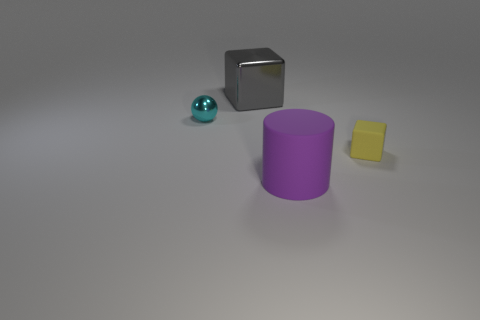Add 2 big purple cylinders. How many objects exist? 6 Subtract all cylinders. How many objects are left? 3 Add 3 cyan metal balls. How many cyan metal balls are left? 4 Add 3 rubber blocks. How many rubber blocks exist? 4 Subtract 0 green blocks. How many objects are left? 4 Subtract all tiny cyan spheres. Subtract all yellow rubber cubes. How many objects are left? 2 